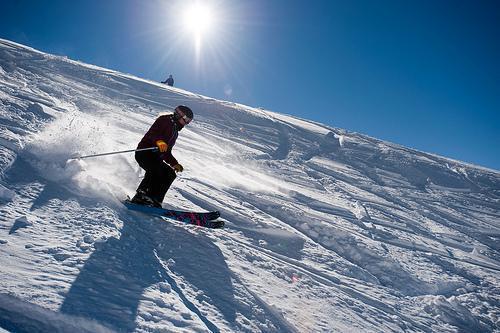How many people are skiing?
Give a very brief answer. 1. 